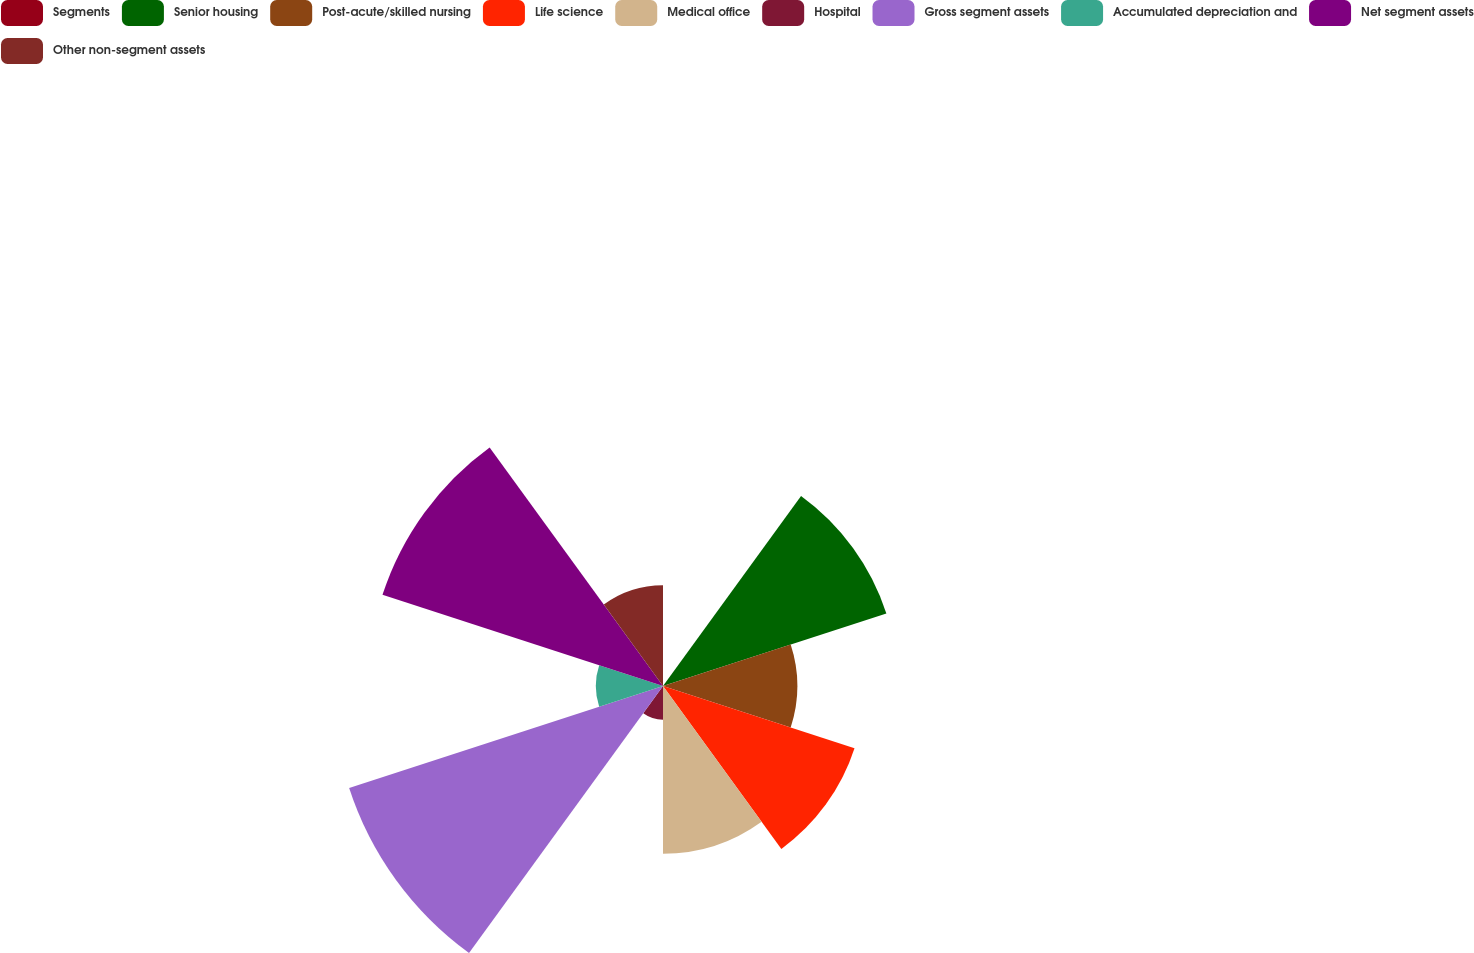<chart> <loc_0><loc_0><loc_500><loc_500><pie_chart><fcel>Segments<fcel>Senior housing<fcel>Post-acute/skilled nursing<fcel>Life science<fcel>Medical office<fcel>Hospital<fcel>Gross segment assets<fcel>Accumulated depreciation and<fcel>Net segment assets<fcel>Other non-segment assets<nl><fcel>0.0%<fcel>15.01%<fcel>8.58%<fcel>12.87%<fcel>10.72%<fcel>2.15%<fcel>21.09%<fcel>4.29%<fcel>18.85%<fcel>6.44%<nl></chart> 